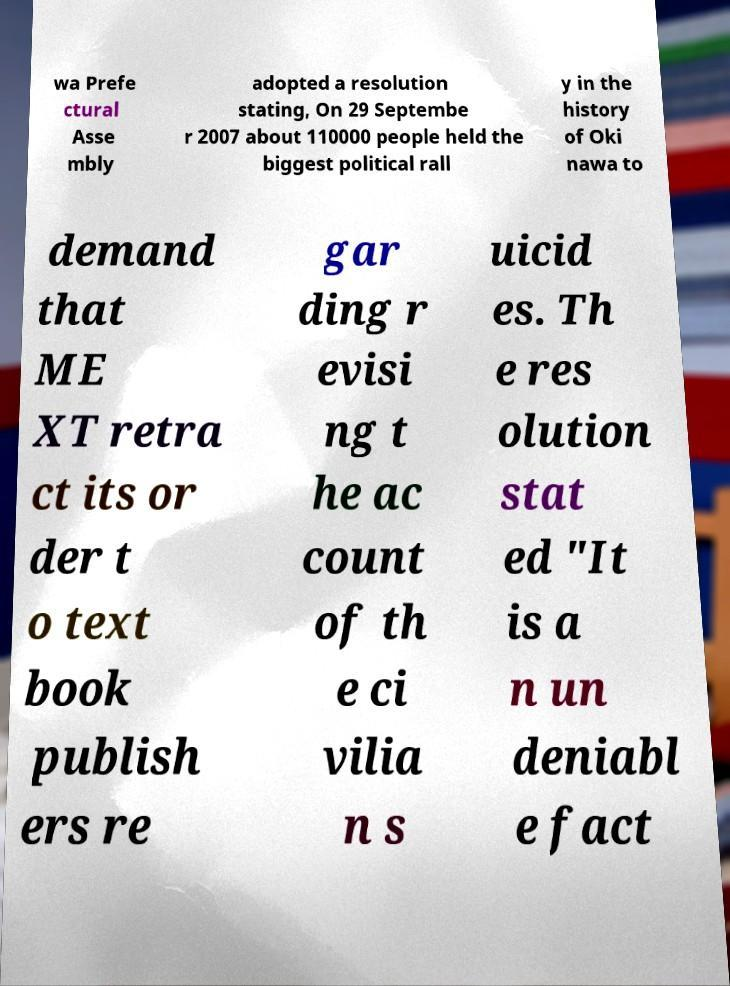Please read and relay the text visible in this image. What does it say? wa Prefe ctural Asse mbly adopted a resolution stating, On 29 Septembe r 2007 about 110000 people held the biggest political rall y in the history of Oki nawa to demand that ME XT retra ct its or der t o text book publish ers re gar ding r evisi ng t he ac count of th e ci vilia n s uicid es. Th e res olution stat ed "It is a n un deniabl e fact 